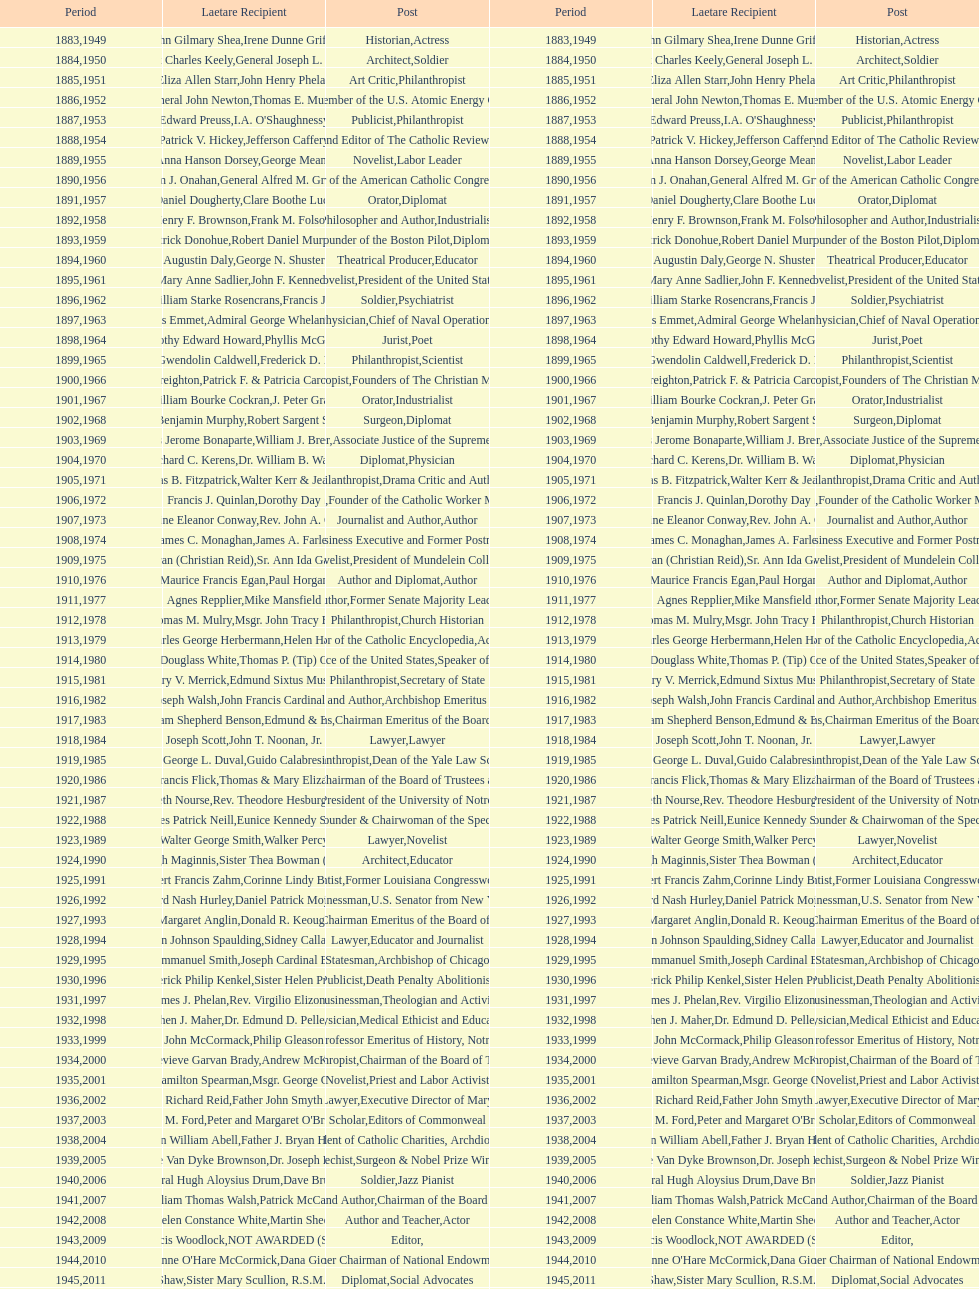Who won the medal after thomas e. murray in 1952? I.A. O'Shaughnessy. 